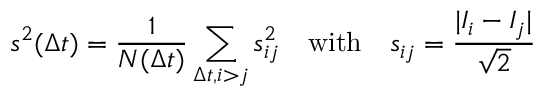<formula> <loc_0><loc_0><loc_500><loc_500>s ^ { 2 } ( \Delta t ) = \frac { 1 } { N ( \Delta t ) } \sum _ { \Delta t , i > j } s _ { i j } ^ { 2 } \quad w i t h \quad s _ { i j } = \frac { | I _ { i } - I _ { j } | } { \sqrt { 2 } }</formula> 